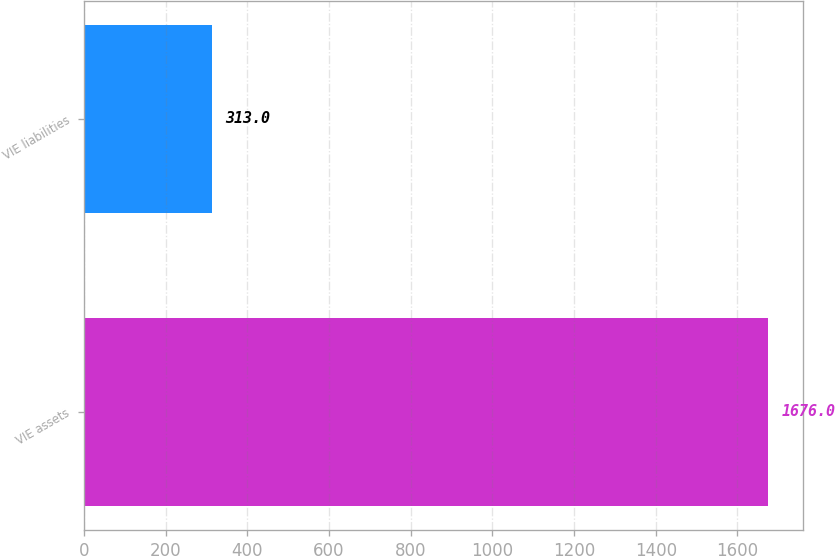<chart> <loc_0><loc_0><loc_500><loc_500><bar_chart><fcel>VIE assets<fcel>VIE liabilities<nl><fcel>1676<fcel>313<nl></chart> 